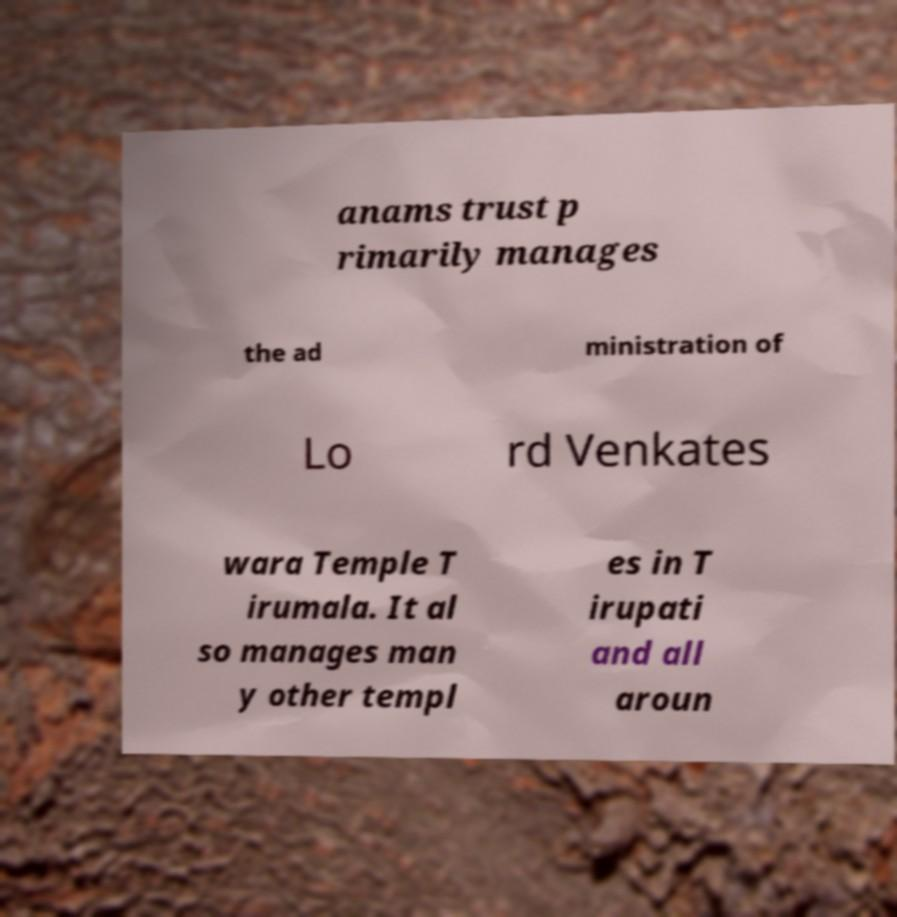Please read and relay the text visible in this image. What does it say? anams trust p rimarily manages the ad ministration of Lo rd Venkates wara Temple T irumala. It al so manages man y other templ es in T irupati and all aroun 